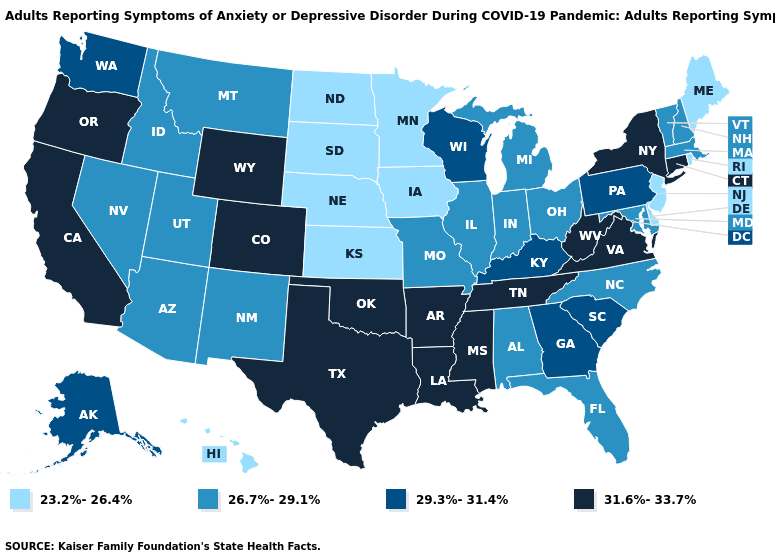Does Louisiana have the lowest value in the South?
Write a very short answer. No. Which states have the lowest value in the West?
Short answer required. Hawaii. Among the states that border Wisconsin , does Illinois have the lowest value?
Be succinct. No. Which states have the lowest value in the MidWest?
Write a very short answer. Iowa, Kansas, Minnesota, Nebraska, North Dakota, South Dakota. Name the states that have a value in the range 23.2%-26.4%?
Answer briefly. Delaware, Hawaii, Iowa, Kansas, Maine, Minnesota, Nebraska, New Jersey, North Dakota, Rhode Island, South Dakota. What is the highest value in the South ?
Quick response, please. 31.6%-33.7%. What is the value of Ohio?
Short answer required. 26.7%-29.1%. Name the states that have a value in the range 31.6%-33.7%?
Write a very short answer. Arkansas, California, Colorado, Connecticut, Louisiana, Mississippi, New York, Oklahoma, Oregon, Tennessee, Texas, Virginia, West Virginia, Wyoming. Does South Dakota have the same value as North Dakota?
Write a very short answer. Yes. Among the states that border Connecticut , does New York have the highest value?
Quick response, please. Yes. Does the map have missing data?
Write a very short answer. No. What is the highest value in the USA?
Concise answer only. 31.6%-33.7%. Name the states that have a value in the range 31.6%-33.7%?
Write a very short answer. Arkansas, California, Colorado, Connecticut, Louisiana, Mississippi, New York, Oklahoma, Oregon, Tennessee, Texas, Virginia, West Virginia, Wyoming. Which states have the lowest value in the USA?
Write a very short answer. Delaware, Hawaii, Iowa, Kansas, Maine, Minnesota, Nebraska, New Jersey, North Dakota, Rhode Island, South Dakota. What is the value of Kentucky?
Concise answer only. 29.3%-31.4%. 